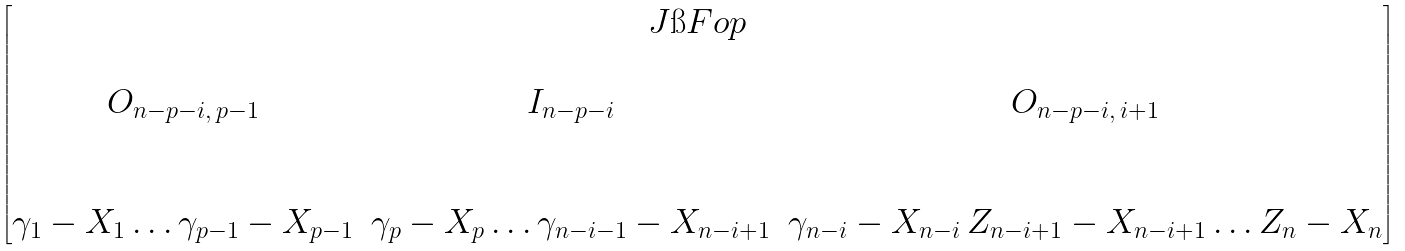Convert formula to latex. <formula><loc_0><loc_0><loc_500><loc_500>\begin{bmatrix} J \i F o p \\ \begin{matrix} \\ O _ { n - p - i , \, p - 1 } & I _ { n - p - i } & O _ { n - p - i , \, i + 1 } \\ & & \\ & & \\ \gamma _ { 1 } - X _ { 1 } \dots \gamma _ { p - 1 } - X _ { p - 1 } & \gamma _ { p } - X _ { p } \dots \gamma _ { n - i - 1 } - X _ { n - i + 1 } & \gamma _ { n - i } - X _ { n - i } \, Z _ { n - i + 1 } - X _ { n - i + 1 } \dots Z _ { n } - X _ { n } \end{matrix} \end{bmatrix}</formula> 